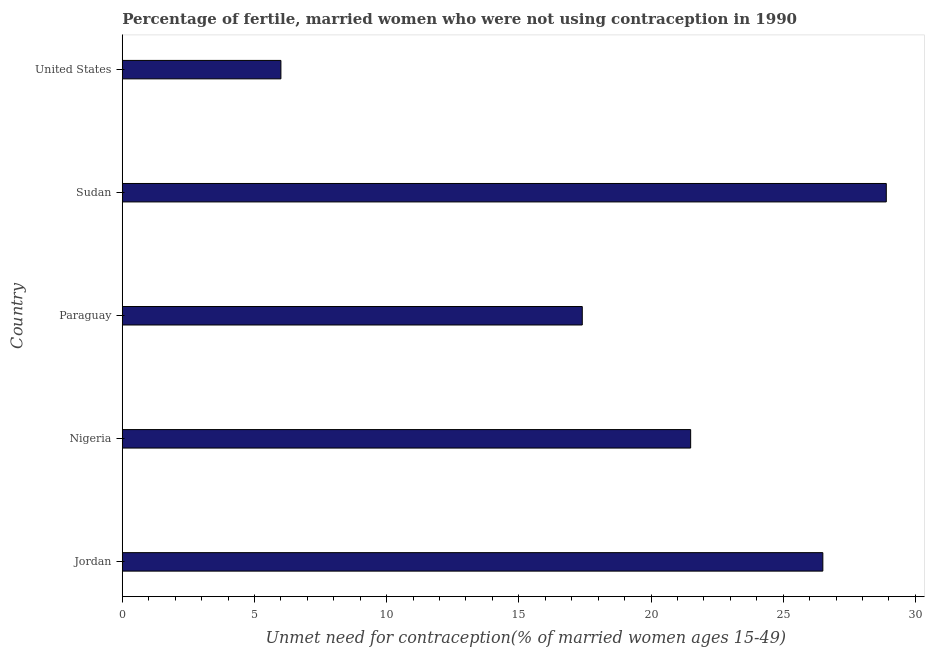Does the graph contain any zero values?
Your answer should be very brief. No. What is the title of the graph?
Make the answer very short. Percentage of fertile, married women who were not using contraception in 1990. What is the label or title of the X-axis?
Provide a short and direct response.  Unmet need for contraception(% of married women ages 15-49). What is the label or title of the Y-axis?
Offer a terse response. Country. What is the number of married women who are not using contraception in United States?
Give a very brief answer. 6. Across all countries, what is the maximum number of married women who are not using contraception?
Give a very brief answer. 28.9. Across all countries, what is the minimum number of married women who are not using contraception?
Offer a very short reply. 6. In which country was the number of married women who are not using contraception maximum?
Make the answer very short. Sudan. In which country was the number of married women who are not using contraception minimum?
Ensure brevity in your answer.  United States. What is the sum of the number of married women who are not using contraception?
Offer a terse response. 100.3. What is the difference between the number of married women who are not using contraception in Jordan and Paraguay?
Keep it short and to the point. 9.1. What is the average number of married women who are not using contraception per country?
Offer a terse response. 20.06. What is the median number of married women who are not using contraception?
Give a very brief answer. 21.5. In how many countries, is the number of married women who are not using contraception greater than 2 %?
Offer a very short reply. 5. What is the ratio of the number of married women who are not using contraception in Jordan to that in Sudan?
Offer a terse response. 0.92. Is the number of married women who are not using contraception in Paraguay less than that in Sudan?
Your answer should be very brief. Yes. Is the difference between the number of married women who are not using contraception in Nigeria and Sudan greater than the difference between any two countries?
Your answer should be compact. No. What is the difference between the highest and the second highest number of married women who are not using contraception?
Keep it short and to the point. 2.4. Is the sum of the number of married women who are not using contraception in Nigeria and United States greater than the maximum number of married women who are not using contraception across all countries?
Give a very brief answer. No. What is the difference between the highest and the lowest number of married women who are not using contraception?
Your response must be concise. 22.9. Are all the bars in the graph horizontal?
Your answer should be very brief. Yes. How many countries are there in the graph?
Offer a terse response. 5. What is the difference between two consecutive major ticks on the X-axis?
Your answer should be compact. 5. Are the values on the major ticks of X-axis written in scientific E-notation?
Provide a short and direct response. No. What is the  Unmet need for contraception(% of married women ages 15-49) of Paraguay?
Offer a very short reply. 17.4. What is the  Unmet need for contraception(% of married women ages 15-49) of Sudan?
Keep it short and to the point. 28.9. What is the  Unmet need for contraception(% of married women ages 15-49) of United States?
Offer a very short reply. 6. What is the difference between the  Unmet need for contraception(% of married women ages 15-49) in Jordan and United States?
Give a very brief answer. 20.5. What is the difference between the  Unmet need for contraception(% of married women ages 15-49) in Nigeria and Sudan?
Provide a succinct answer. -7.4. What is the difference between the  Unmet need for contraception(% of married women ages 15-49) in Sudan and United States?
Ensure brevity in your answer.  22.9. What is the ratio of the  Unmet need for contraception(% of married women ages 15-49) in Jordan to that in Nigeria?
Your answer should be very brief. 1.23. What is the ratio of the  Unmet need for contraception(% of married women ages 15-49) in Jordan to that in Paraguay?
Offer a very short reply. 1.52. What is the ratio of the  Unmet need for contraception(% of married women ages 15-49) in Jordan to that in Sudan?
Give a very brief answer. 0.92. What is the ratio of the  Unmet need for contraception(% of married women ages 15-49) in Jordan to that in United States?
Offer a terse response. 4.42. What is the ratio of the  Unmet need for contraception(% of married women ages 15-49) in Nigeria to that in Paraguay?
Your response must be concise. 1.24. What is the ratio of the  Unmet need for contraception(% of married women ages 15-49) in Nigeria to that in Sudan?
Keep it short and to the point. 0.74. What is the ratio of the  Unmet need for contraception(% of married women ages 15-49) in Nigeria to that in United States?
Make the answer very short. 3.58. What is the ratio of the  Unmet need for contraception(% of married women ages 15-49) in Paraguay to that in Sudan?
Give a very brief answer. 0.6. What is the ratio of the  Unmet need for contraception(% of married women ages 15-49) in Sudan to that in United States?
Your answer should be very brief. 4.82. 